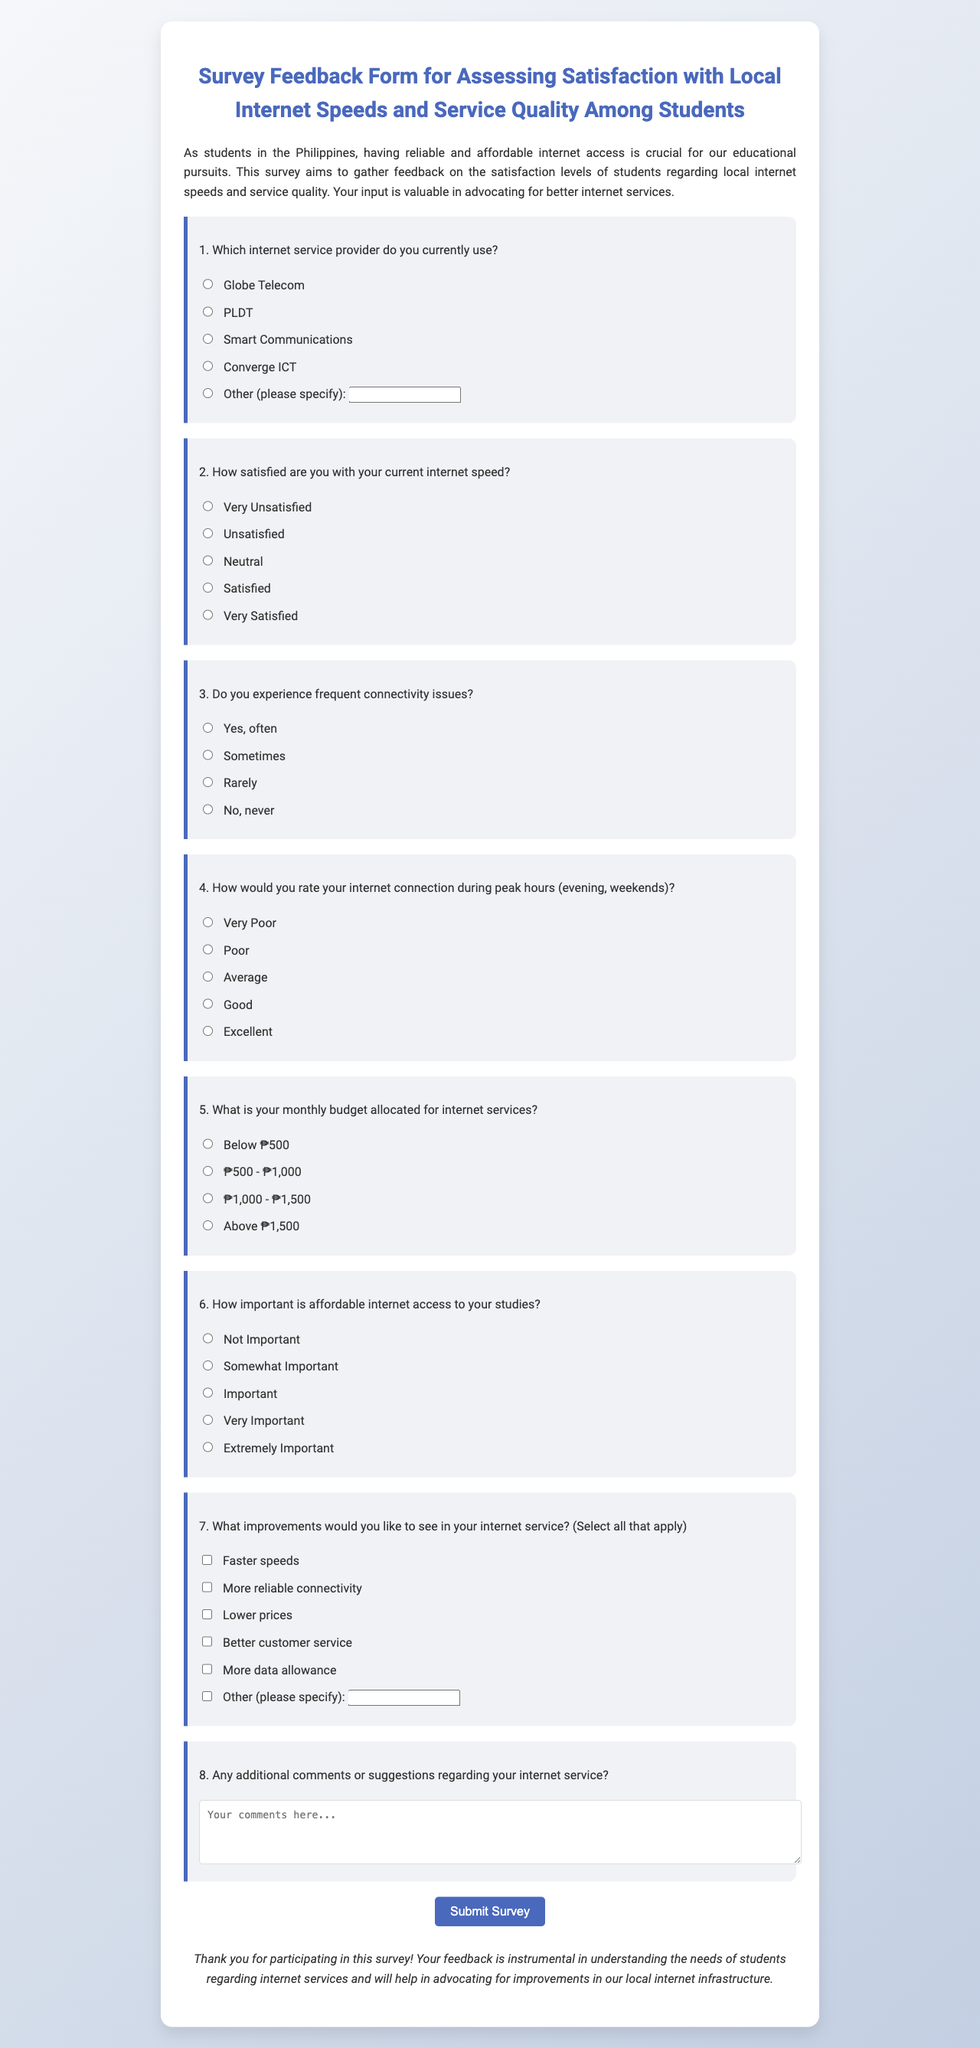What is the title of the survey? The title is specified in the header of the document, which indicates the focus of the survey.
Answer: Survey Feedback Form for Assessing Satisfaction with Local Internet Speeds and Service Quality Among Students How many radio buttons are there for internet service providers? The document lists the number of radio buttons under the question regarding internet service providers.
Answer: 5 What is the maximum monthly budget category listed? The budget question specifies the range of monthly budgets that can be selected by respondents.
Answer: Above ₱1,500 What is one suggested improvement for internet service mentioned in the form? The document lists several options for improvements students can select, highlighting the common issues faced.
Answer: Faster speeds How is affordable internet access perceived in terms of importance for studies? The form allows respondents to indicate the significance of affordable internet access, reflecting students' views.
Answer: Extremely Important 